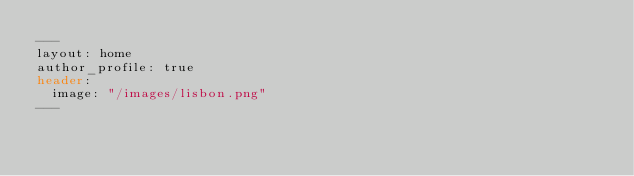<code> <loc_0><loc_0><loc_500><loc_500><_HTML_>---
layout: home
author_profile: true
header:
  image: "/images/lisbon.png"
---
</code> 